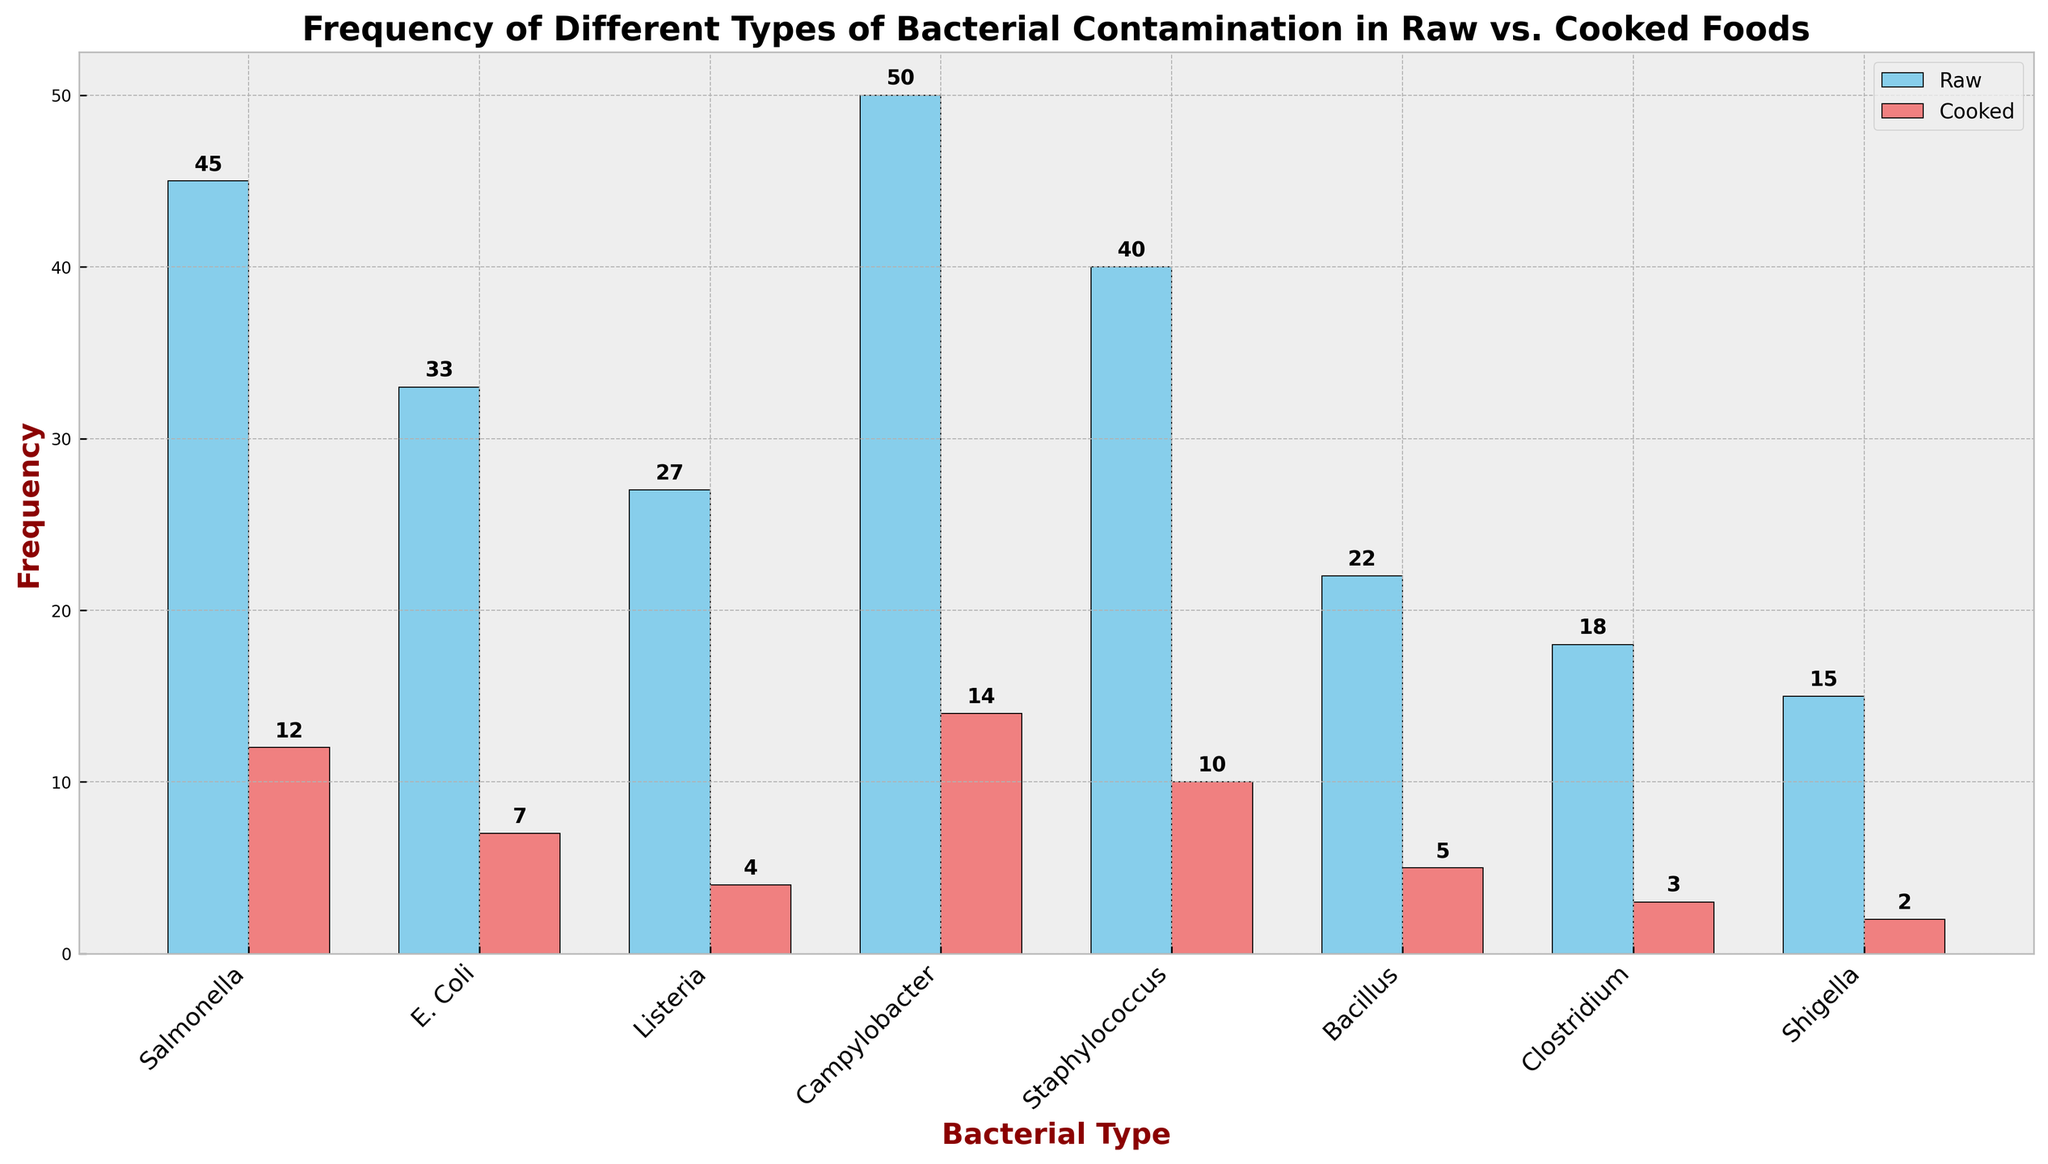What type of bacterial contamination has the highest frequency in raw foods? The bar corresponding to Campylobacter in raw foods is the tallest, indicating it has the highest frequency.
Answer: Campylobacter Which type of bacterial contamination shows the greatest reduction in frequency from raw to cooked foods? Calculate the difference in frequency for each bacterial type: Salmonella (45-12=33), E. Coli (33-7=26), Listeria (27-4=23), Campylobacter (50-14=36), Staphylococcus (40-10=30), Bacillus (22-5=17), Clostridium (18-3=15), Shigella (15-2=13). Campylobacter's reduction (36) is the greatest.
Answer: Campylobacter How does the frequency of Salmonella in raw foods compare to cooked foods? Check the height of the bars corresponding to Salmonella. The raw food bar is much taller (45) compared to the cooked food bar (12).
Answer: Higher in raw foods What is the average frequency of bacterial contamination in cooked foods? Summing the cooked food frequencies: 12 + 7 + 4 + 14 + 10 + 5 + 3 + 2 = 57. There are 8 types of bacteria, so the average is 57 / 8.
Answer: 7.125 What is the total frequency of bacterial contamination in both raw and cooked foods for Listeria and E.Coli combined? Add up the frequencies for both Listeria and E.Coli in raw and cooked foods: Listeria (27 + 4) + E.Coli (33 + 7).
Answer: 71 Which bacterial type has almost the same frequency in raw and cooked foods when looking comparatively? Examining the bars, both raw and cooked frequencies: Campylobacter (50 vs. 14) is not close; Bacillus (22 vs. 5) shows divergence; Salmonella (45 vs. 12) is not close; Clostridium (18 vs. 3) is divergent. Look at the rest and find E.Coli (33 vs. 7) reasonably closer but not almost the same. Continue checking until: No type shows almost same frequency.
Answer: None By what percentage does the frequency of Staphylococcus decrease from raw to cooked foods? Calculate the percentage decrease: ((40 - 10) / 40) * 100. The decrease is 30; 30 / 40 = 0.75; 0.75 * 100 = 75%
Answer: 75% Which raw foods contain bacterial types with frequencies greater than 30? Check the raw frequencies: Salmonella (45), E. Coli (33), Campylobacter (50), Staphylococcus (40). These frequencies are all above 30.
Answer: Salmonella, E. Coli, Campylobacter, Staphylococcus What is the difference in frequency between the highest and lowest bacterial contamination in raw foods? The highest frequency in raw foods is Campylobacter (50) and the lowest is Shigella (15). Calculate the difference: 50 - 15.
Answer: 35 